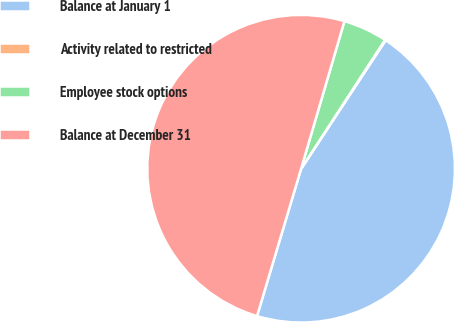Convert chart to OTSL. <chart><loc_0><loc_0><loc_500><loc_500><pie_chart><fcel>Balance at January 1<fcel>Activity related to restricted<fcel>Employee stock options<fcel>Balance at December 31<nl><fcel>45.36%<fcel>0.08%<fcel>4.64%<fcel>49.92%<nl></chart> 